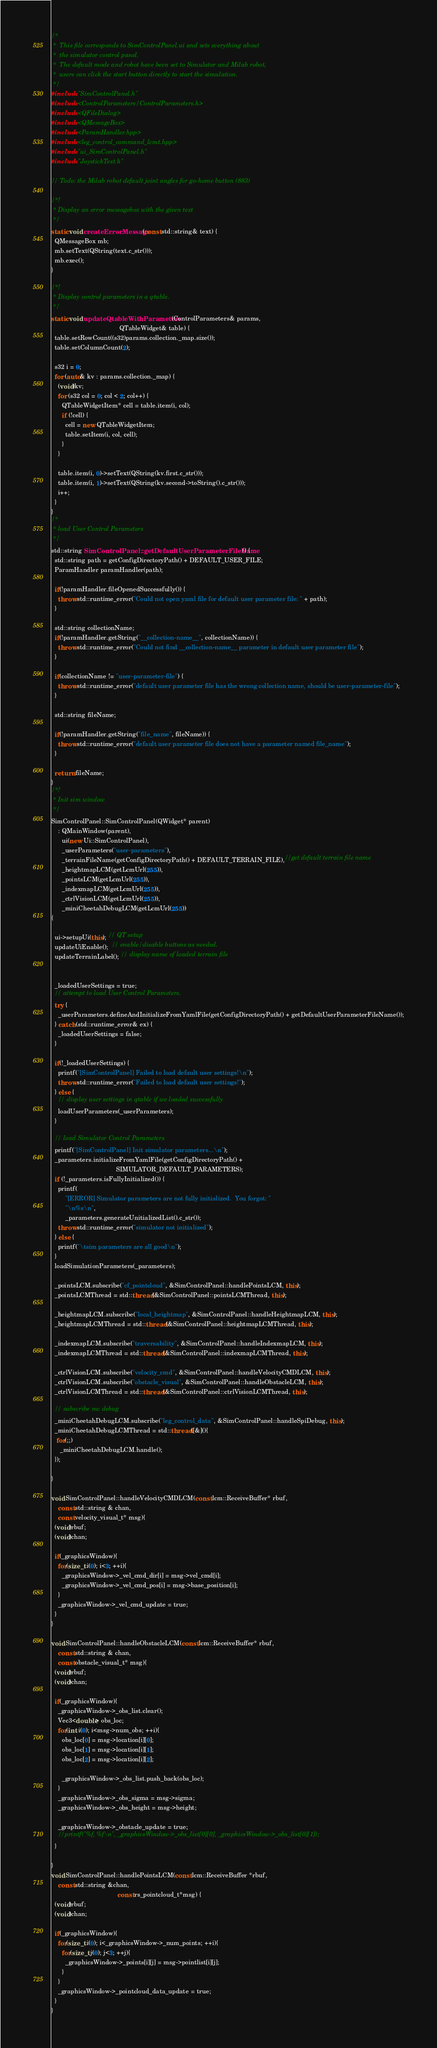<code> <loc_0><loc_0><loc_500><loc_500><_C++_>/*
 *  This file corresponds to SimControlPanel.ui and sets everything about
 *  the simulator control panel.
 *  The default mode and robot have been set to Simulator and Milab robot,
 *  users can click the start button directly to start the simulation.
 */
#include "SimControlPanel.h"
#include <ControlParameters/ControlParameters.h>
#include <QFileDialog>
#include <QMessageBox>
#include <ParamHandler.hpp>
#include <leg_control_command_lcmt.hpp>
#include "ui_SimControlPanel.h"
#include "JoystickTest.h"

// Todo: the Milab robot default joint angles for go-home button (883)

/*!
 * Display an error messagebox with the given text
 */
static void createErrorMessage(const std::string& text) {
  QMessageBox mb;
  mb.setText(QString(text.c_str()));
  mb.exec();
}

/*!
 * Display control parameters in a qtable.
 */
static void updateQtableWithParameters(ControlParameters& params,
                                       QTableWidget& table) {
  table.setRowCount((s32)params.collection._map.size());
  table.setColumnCount(2);

  s32 i = 0;
  for (auto& kv : params.collection._map) {
    (void)kv;
    for (s32 col = 0; col < 2; col++) {
      QTableWidgetItem* cell = table.item(i, col);
      if (!cell) {
        cell = new QTableWidgetItem;
        table.setItem(i, col, cell);
      }
    }

    table.item(i, 0)->setText(QString(kv.first.c_str()));
    table.item(i, 1)->setText(QString(kv.second->toString().c_str()));
    i++;
  }
}
/*
 * load User Control Parameters
 */
std::string SimControlPanel::getDefaultUserParameterFileName() {
  std::string path = getConfigDirectoryPath() + DEFAULT_USER_FILE;
  ParamHandler paramHandler(path);

  if(!paramHandler.fileOpenedSuccessfully()) {
    throw std::runtime_error("Could not open yaml file for default user parameter file: " + path);
  }

  std::string collectionName;
  if(!paramHandler.getString("__collection-name__", collectionName)) {
    throw std::runtime_error("Could not find __collection-name__ parameter in default user parameter file");
  }

  if(collectionName != "user-parameter-file") {
    throw std::runtime_error("default user parameter file has the wrong collection name, should be user-parameter-file");
  }

  std::string fileName;

  if(!paramHandler.getString("file_name", fileName)) {
    throw std::runtime_error("default user parameter file does not have a parameter named file_name");
  }

  return fileName;
}
/*!
 * Init sim window
 */
SimControlPanel::SimControlPanel(QWidget* parent)
    : QMainWindow(parent),
      ui(new Ui::SimControlPanel),
      _userParameters("user-parameters"),
      _terrainFileName(getConfigDirectoryPath() + DEFAULT_TERRAIN_FILE),//get default terrain file name
      _heightmapLCM(getLcmUrl(255)),
      _pointsLCM(getLcmUrl(255)),
      _indexmapLCM(getLcmUrl(255)),
      _ctrlVisionLCM(getLcmUrl(255)),
      _miniCheetahDebugLCM(getLcmUrl(255))
{

  ui->setupUi(this); // QT setup
  updateUiEnable();  // enable/disable buttons as needed.
  updateTerrainLabel(); // display name of loaded terrain file


  _loadedUserSettings = true;
  // attempt to load User Control Parameters.
  try {
    _userParameters.defineAndInitializeFromYamlFile(getConfigDirectoryPath() + getDefaultUserParameterFileName());
  } catch (std::runtime_error& ex) {
    _loadedUserSettings = false;
  }

  if(!_loadedUserSettings) {
    printf("[SimControlPanel] Failed to load default user settings!\n");
    throw std::runtime_error("Failed to load default user settings!");
  } else {
    // display user settings in qtable if we loaded successfully
    loadUserParameters(_userParameters);
  }

  // load Simulator Control Parameters
  printf("[SimControlPanel] Init simulator parameters...\n");
  _parameters.initializeFromYamlFile(getConfigDirectoryPath() +
                                     SIMULATOR_DEFAULT_PARAMETERS);
  if (!_parameters.isFullyInitialized()) {
    printf(
        "[ERROR] Simulator parameters are not fully initialized.  You forgot: "
        "\n%s\n",
        _parameters.generateUnitializedList().c_str());
    throw std::runtime_error("simulator not initialized");
  } else {
    printf("\tsim parameters are all good\n");
  }
  loadSimulationParameters(_parameters);

  _pointsLCM.subscribe("cf_pointcloud", &SimControlPanel::handlePointsLCM, this);
  _pointsLCMThread = std::thread(&SimControlPanel::pointsLCMThread, this); 

  _heightmapLCM.subscribe("local_heightmap", &SimControlPanel::handleHeightmapLCM, this);
  _heightmapLCMThread = std::thread(&SimControlPanel::heightmapLCMThread, this);

  _indexmapLCM.subscribe("traversability", &SimControlPanel::handleIndexmapLCM, this);
  _indexmapLCMThread = std::thread(&SimControlPanel::indexmapLCMThread, this);

  _ctrlVisionLCM.subscribe("velocity_cmd", &SimControlPanel::handleVelocityCMDLCM, this);
  _ctrlVisionLCM.subscribe("obstacle_visual", &SimControlPanel::handleObstacleLCM, this);
  _ctrlVisionLCMThread = std::thread(&SimControlPanel::ctrlVisionLCMThread, this);

  // subscribe mc debug
  _miniCheetahDebugLCM.subscribe("leg_control_data", &SimControlPanel::handleSpiDebug, this);
  _miniCheetahDebugLCMThread = std::thread([&](){
   for(;;)
     _miniCheetahDebugLCM.handle();
  });

}

void SimControlPanel::handleVelocityCMDLCM(const lcm::ReceiveBuffer* rbuf, 
    const std::string & chan,
    const velocity_visual_t* msg){
  (void)rbuf;
  (void)chan;
 
  if(_graphicsWindow){
    for(size_t i(0); i<3; ++i){
      _graphicsWindow->_vel_cmd_dir[i] = msg->vel_cmd[i];
      _graphicsWindow->_vel_cmd_pos[i] = msg->base_position[i];
    }
    _graphicsWindow->_vel_cmd_update = true;
  }
}

void SimControlPanel::handleObstacleLCM(const lcm::ReceiveBuffer* rbuf, 
    const std::string & chan,
    const obstacle_visual_t* msg){
  (void)rbuf;
  (void)chan;
 
  if(_graphicsWindow){
    _graphicsWindow->_obs_list.clear();
    Vec3<double> obs_loc;
    for(int i(0); i<msg->num_obs; ++i){
      obs_loc[0] = msg->location[i][0];
      obs_loc[1] = msg->location[i][1];
      obs_loc[2] = msg->location[i][2];

      _graphicsWindow->_obs_list.push_back(obs_loc);
    }
    _graphicsWindow->_obs_sigma = msg->sigma;
    _graphicsWindow->_obs_height = msg->height;

    _graphicsWindow->_obstacle_update = true;
    //printf("%f, %f\n", _graphicsWindow->_obs_list[0][0], _graphicsWindow->_obs_list[0][1]);
  }

}
void SimControlPanel::handlePointsLCM(const lcm::ReceiveBuffer *rbuf,
    const std::string &chan,
                                      const rs_pointcloud_t*msg) {
  (void)rbuf;
  (void)chan;

  if(_graphicsWindow){
    for(size_t i(0); i<_graphicsWindow->_num_points; ++i){
      for(size_t j(0); j<3; ++j){
        _graphicsWindow->_points[i][j] = msg->pointlist[i][j];
      }
    }
    _graphicsWindow->_pointcloud_data_update = true;
  }
}
</code> 